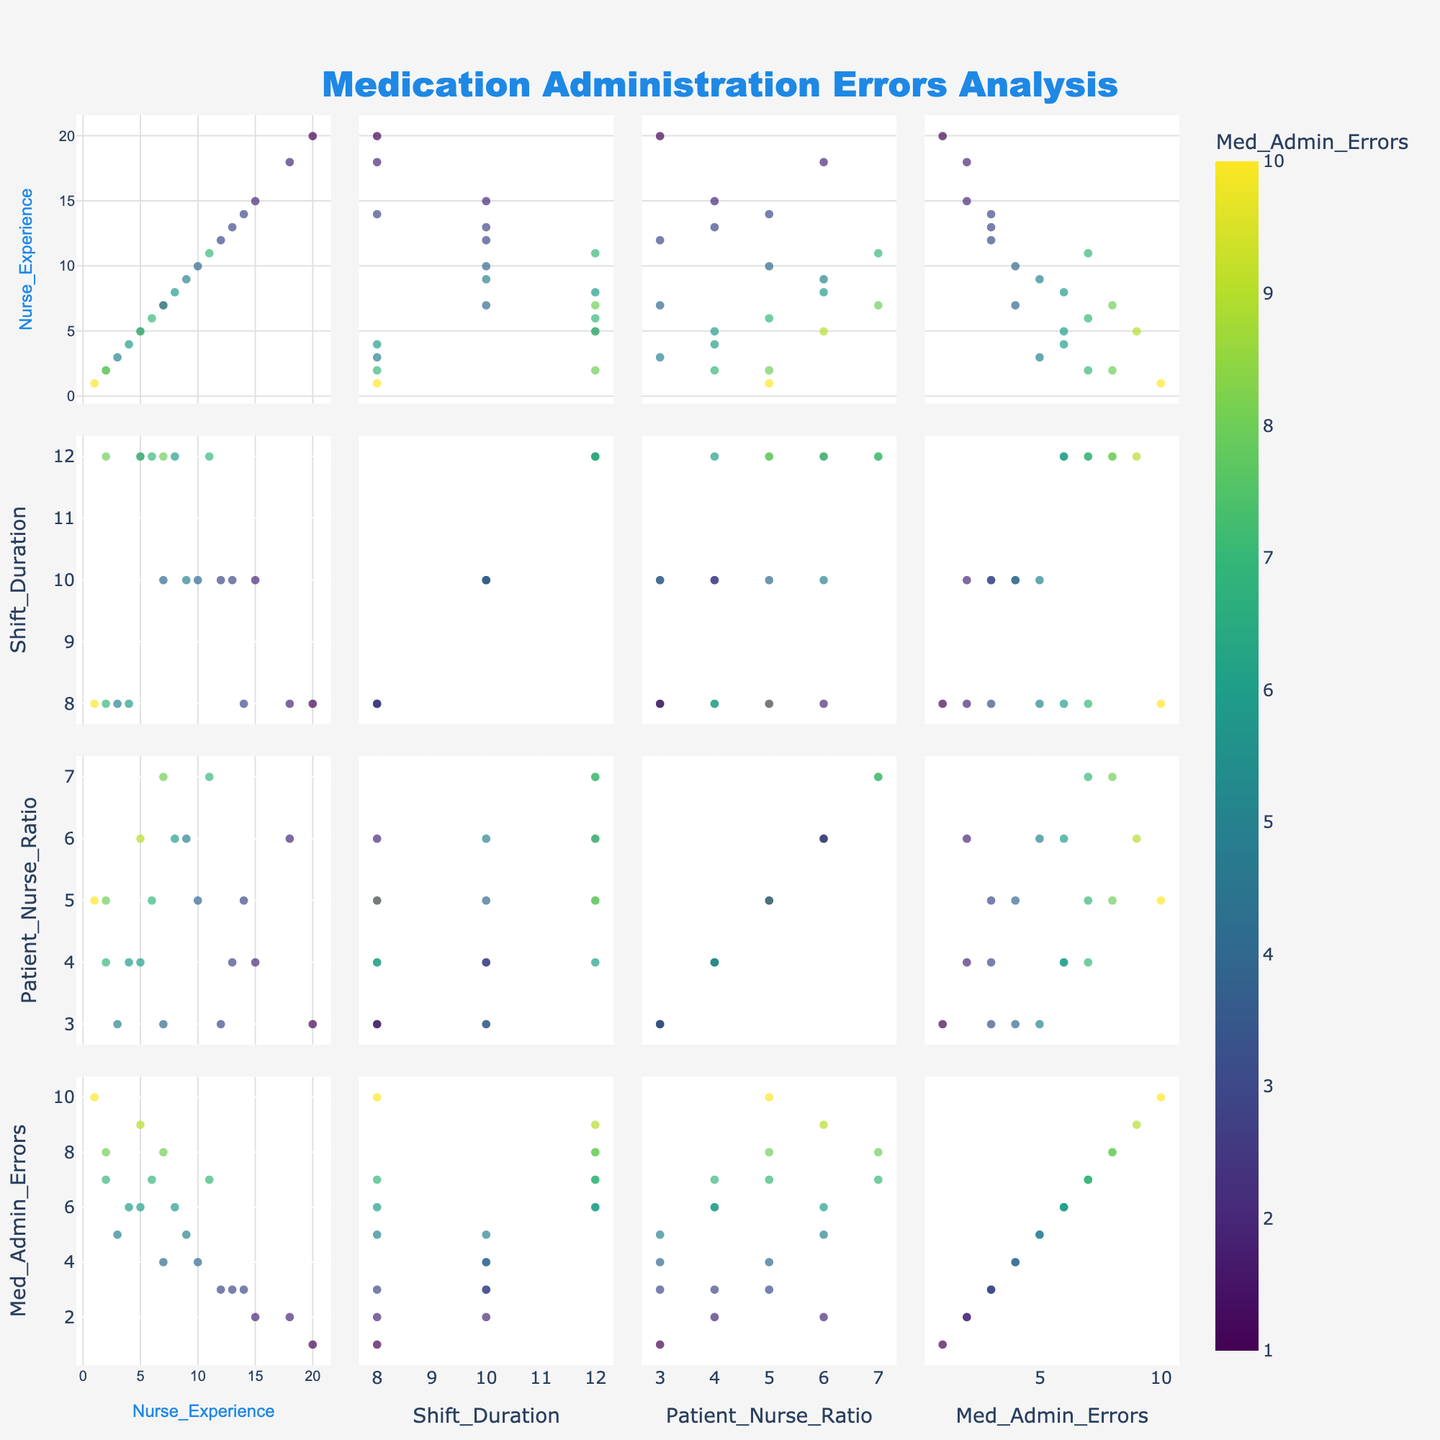what is the title of the scatterplot matrix? The title is displayed at the top center of the scatterplot matrix. It reads "Medication Administration Errors Analysis," highlighted by its large font size and distinctive color.
Answer: Medication Administration Errors Analysis How many dimensions are used in this scatterplot matrix? There are four dimensions used in the scatterplot matrix. They are 'Nurse_Experience', 'Shift_Duration', 'Patient_Nurse_Ratio', and 'Med_Admin_Errors'.
Answer: four What color scale is used for the 'Med_Admin_Errors' attribute? The color scale used for the 'Med_Admin_Errors' attribute is 'Viridis.' This can be determined by the gradient color bar, indicating the use of the Viridis color palette, ranging from dark to bright shades.
Answer: Viridis Which scatter plot shows the relationship between 'Nurse_Experience' and 'Med_Admin_Errors'? Identify the scatter plot positioned at the intersection of the 'Nurse_Experience' row and the 'Med_Admin_Errors' column. This shows the relationship between these two variables.
Answer: The plot at the intersection of the 'Nurse_Experience' row and 'Med_Admin_Errors' column How does 'Nurse_Experience' appear to affect 'Med_Admin_Errors'? By observing the scatter plot with 'Nurse_Experience' on one axis and 'Med_Admin_Errors' on the other, a general trend suggests that as 'Nurse_Experience' increases, 'Med_Admin_Errors' tend to decrease. This is seen through the points clustering lower on the 'Med_Admin_Errors' scale with higher 'Nurse_Experience'.
Answer: As 'Nurse_Experience' increases, 'Med_Admin_Errors' generally decrease Which axis titles are present in the scatterplot matrix? The axis titles visible are 'Nurse_Experience', 'Shift_Duration', 'Patient_Nurse_Ratio', and 'Med_Admin_Errors'. Each of these dimensions is labeled along both the rows and columns of the scatterplot matrix.
Answer: 'Nurse_Experience', 'Shift_Duration', 'Patient_Nurse_Ratio', 'Med_Admin_Errors' Does 'Shift_Duration' seem to have a strong correlation with 'Med_Admin_Errors'? To determine this, look at the scatter plot where 'Shift_Duration' and 'Med_Admin_Errors' intersect. The points seem widely scattered, indicating a weak or no clear correlation between 'Shift_Duration' and 'Med_Admin_Errors'.
Answer: No, it does not seem to have a strong correlation What is the trend for 'Patient_Nurse_Ratio' related to 'Med_Admin_Errors'? By analyzing the scatter plots where 'Patient_Nurse_Ratio' intersects with 'Med_Admin_Errors', there appears to be no strong linear relationship observable from the scatter, implying no clear trend.
Answer: No clear trend Which variable seems to have the least variability in its range? By observing the scatter plots and the spread of points within each variable's range, 'Shift_Duration' has relatively consistent values mostly around 8 or 12 hours, showing the least variability in comparison to the other dimensions.
Answer: 'Shift_Duration' What can be inferred about the relationship between 'Patient_Nurse_Ratio' and 'Nurse_Experience'? Inspecting the scatter plot at the intersection of 'Patient_Nurse_Ratio' and 'Nurse_Experience', a mild negative trend can be observed, where higher 'Nurse_Experience' tends to correspond with lower 'Patient_Nurse_Ratio'.
Answer: A mild negative relationship 